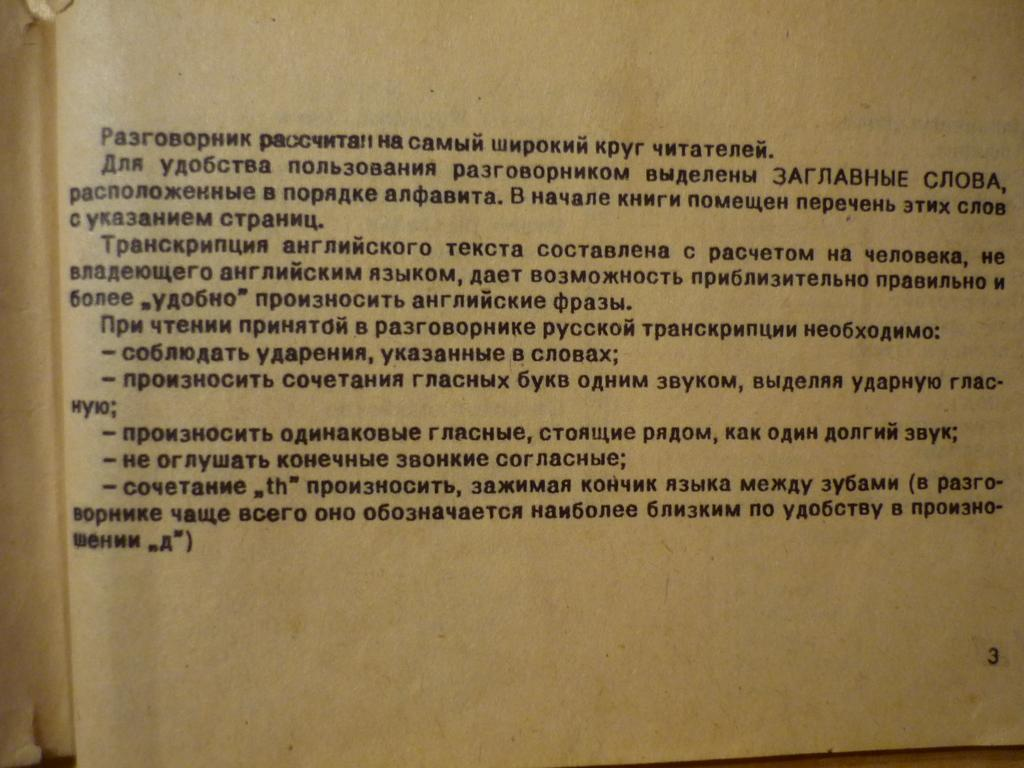Provide a one-sentence caption for the provided image. A book is open to page number 3. 